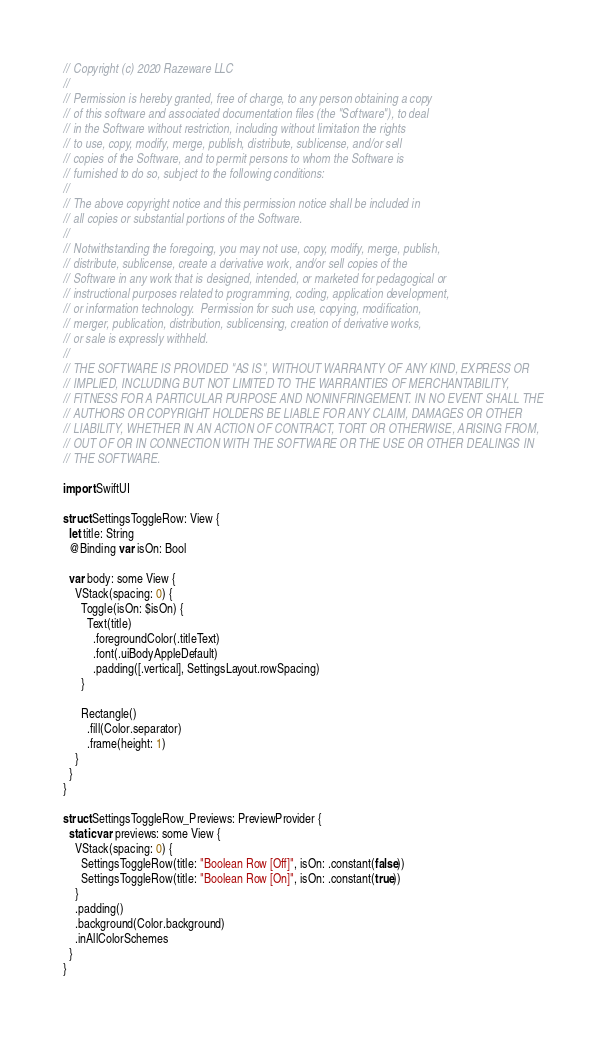<code> <loc_0><loc_0><loc_500><loc_500><_Swift_>// Copyright (c) 2020 Razeware LLC
//
// Permission is hereby granted, free of charge, to any person obtaining a copy
// of this software and associated documentation files (the "Software"), to deal
// in the Software without restriction, including without limitation the rights
// to use, copy, modify, merge, publish, distribute, sublicense, and/or sell
// copies of the Software, and to permit persons to whom the Software is
// furnished to do so, subject to the following conditions:
//
// The above copyright notice and this permission notice shall be included in
// all copies or substantial portions of the Software.
//
// Notwithstanding the foregoing, you may not use, copy, modify, merge, publish,
// distribute, sublicense, create a derivative work, and/or sell copies of the
// Software in any work that is designed, intended, or marketed for pedagogical or
// instructional purposes related to programming, coding, application development,
// or information technology.  Permission for such use, copying, modification,
// merger, publication, distribution, sublicensing, creation of derivative works,
// or sale is expressly withheld.
//
// THE SOFTWARE IS PROVIDED "AS IS", WITHOUT WARRANTY OF ANY KIND, EXPRESS OR
// IMPLIED, INCLUDING BUT NOT LIMITED TO THE WARRANTIES OF MERCHANTABILITY,
// FITNESS FOR A PARTICULAR PURPOSE AND NONINFRINGEMENT. IN NO EVENT SHALL THE
// AUTHORS OR COPYRIGHT HOLDERS BE LIABLE FOR ANY CLAIM, DAMAGES OR OTHER
// LIABILITY, WHETHER IN AN ACTION OF CONTRACT, TORT OR OTHERWISE, ARISING FROM,
// OUT OF OR IN CONNECTION WITH THE SOFTWARE OR THE USE OR OTHER DEALINGS IN
// THE SOFTWARE.

import SwiftUI

struct SettingsToggleRow: View {
  let title: String
  @Binding var isOn: Bool
  
  var body: some View {
    VStack(spacing: 0) {
      Toggle(isOn: $isOn) {
        Text(title)
          .foregroundColor(.titleText)
          .font(.uiBodyAppleDefault)
          .padding([.vertical], SettingsLayout.rowSpacing)
      }
      
      Rectangle()
        .fill(Color.separator)
        .frame(height: 1)
    }
  }
}

struct SettingsToggleRow_Previews: PreviewProvider {
  static var previews: some View {
    VStack(spacing: 0) {
      SettingsToggleRow(title: "Boolean Row [Off]", isOn: .constant(false))
      SettingsToggleRow(title: "Boolean Row [On]", isOn: .constant(true))
    }
    .padding()
    .background(Color.background)
    .inAllColorSchemes
  }
}
</code> 